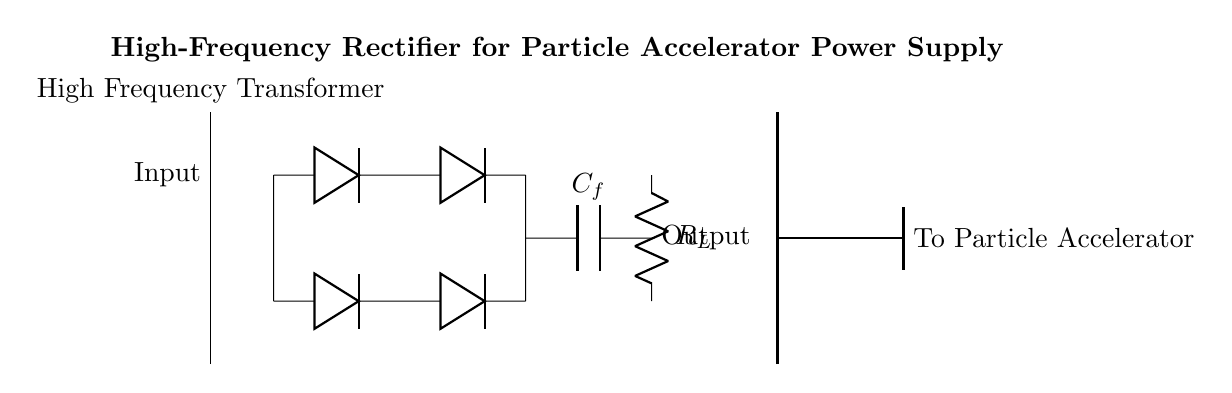What type of rectifier is shown? The circuit diagram shows a bridge rectifier, which consists of four diodes arranged in a bridge configuration to convert alternating current to direct current.
Answer: Bridge rectifier How many diodes are used in this rectifier? The bridge rectifier configuration contains four diodes for the conversion of AC to DC.
Answer: Four diodes What is the purpose of the capacitor labeled \(C_f\)? The capacitor \(C_f\) is used as a smoothing capacitor to reduce the ripple in the output voltage after rectification, providing a more stable DC signal.
Answer: Smoothing What does the symbol on the right represent? The symbol on the right represents the output to the particle accelerator, indicating where the rectified voltage is being sent for usage.
Answer: Particle accelerator How is the transformer described in this circuit? The transformer is described as a high-frequency transformer, which suggests that it operates at a higher frequency than typical transformers for efficient conversion of voltage levels in the circuit.
Answer: High frequency What is the load resistance value denoted in the circuit diagram? The load resistance \(R_L\) is shown as a variable resistor, indicating its function can depend on the specific application requirements. The exact value is not specified in the diagram.
Answer: Not specified Which component connects the upper and lower diode pairs? The short connection between the upper and lower diode pairs ensures that the diodes work together in the bridge configuration, allowing current flow during both halves of the AC cycle.
Answer: Short connection 